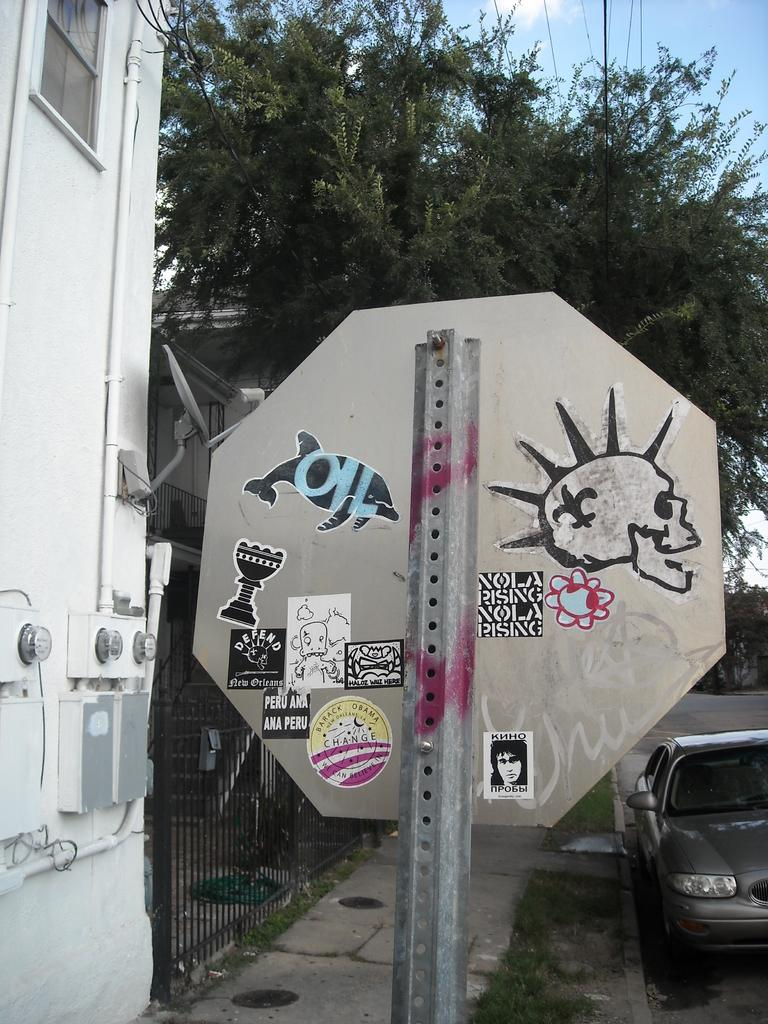What is the main object in the image? There is a sign board in the image. What can be seen behind the sign board? There is a tree behind the sign board. What type of vehicle is on the road in the image? A car is present on the road in the image. What is located on the left side of the image? There is a gate and a building on the left side of the image. What type of joke is being told by the tree in the image? There is no joke being told by the tree in the image; it is a stationary object. 